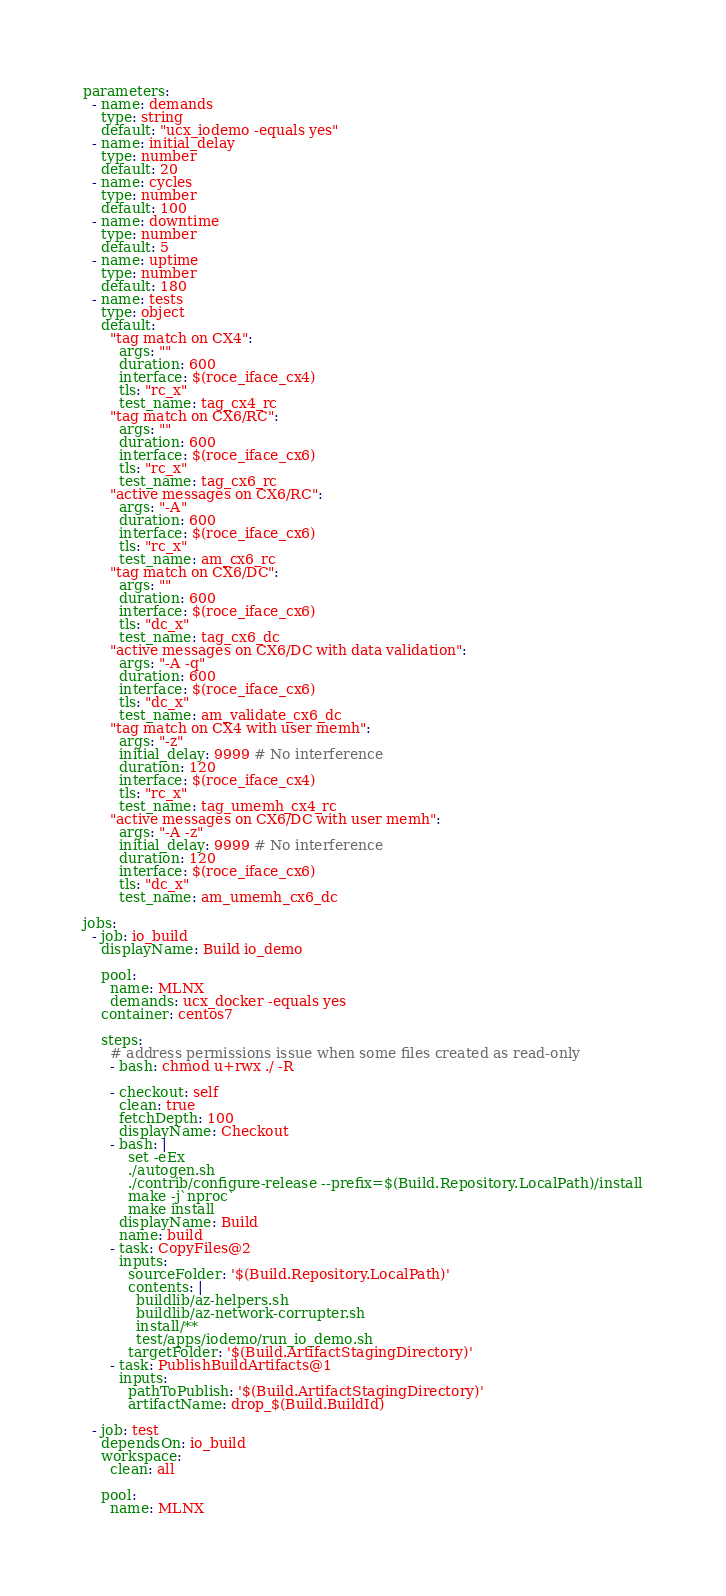<code> <loc_0><loc_0><loc_500><loc_500><_YAML_>parameters:
  - name: demands
    type: string
    default: "ucx_iodemo -equals yes"
  - name: initial_delay
    type: number
    default: 20
  - name: cycles
    type: number
    default: 100
  - name: downtime
    type: number
    default: 5
  - name: uptime
    type: number
    default: 180
  - name: tests
    type: object
    default:
      "tag match on CX4":
        args: ""
        duration: 600
        interface: $(roce_iface_cx4)
        tls: "rc_x"
        test_name: tag_cx4_rc
      "tag match on CX6/RC":
        args: ""
        duration: 600
        interface: $(roce_iface_cx6)
        tls: "rc_x"
        test_name: tag_cx6_rc
      "active messages on CX6/RC":
        args: "-A"
        duration: 600
        interface: $(roce_iface_cx6)
        tls: "rc_x"
        test_name: am_cx6_rc
      "tag match on CX6/DC":
        args: ""
        duration: 600
        interface: $(roce_iface_cx6)
        tls: "dc_x"
        test_name: tag_cx6_dc
      "active messages on CX6/DC with data validation":
        args: "-A -q"
        duration: 600
        interface: $(roce_iface_cx6)
        tls: "dc_x"
        test_name: am_validate_cx6_dc
      "tag match on CX4 with user memh":
        args: "-z"
        initial_delay: 9999 # No interference
        duration: 120
        interface: $(roce_iface_cx4)
        tls: "rc_x"
        test_name: tag_umemh_cx4_rc
      "active messages on CX6/DC with user memh":
        args: "-A -z"
        initial_delay: 9999 # No interference
        duration: 120
        interface: $(roce_iface_cx6)
        tls: "dc_x"
        test_name: am_umemh_cx6_dc

jobs:
  - job: io_build
    displayName: Build io_demo

    pool:
      name: MLNX
      demands: ucx_docker -equals yes
    container: centos7

    steps:
      # address permissions issue when some files created as read-only
      - bash: chmod u+rwx ./ -R

      - checkout: self
        clean: true
        fetchDepth: 100
        displayName: Checkout
      - bash: |
          set -eEx
          ./autogen.sh
          ./contrib/configure-release --prefix=$(Build.Repository.LocalPath)/install
          make -j`nproc`
          make install
        displayName: Build
        name: build
      - task: CopyFiles@2
        inputs:
          sourceFolder: '$(Build.Repository.LocalPath)'
          contents: |
            buildlib/az-helpers.sh
            buildlib/az-network-corrupter.sh
            install/**
            test/apps/iodemo/run_io_demo.sh
          targetFolder: '$(Build.ArtifactStagingDirectory)'
      - task: PublishBuildArtifacts@1
        inputs:
          pathToPublish: '$(Build.ArtifactStagingDirectory)'
          artifactName: drop_$(Build.BuildId)

  - job: test
    dependsOn: io_build
    workspace:
      clean: all

    pool:
      name: MLNX</code> 